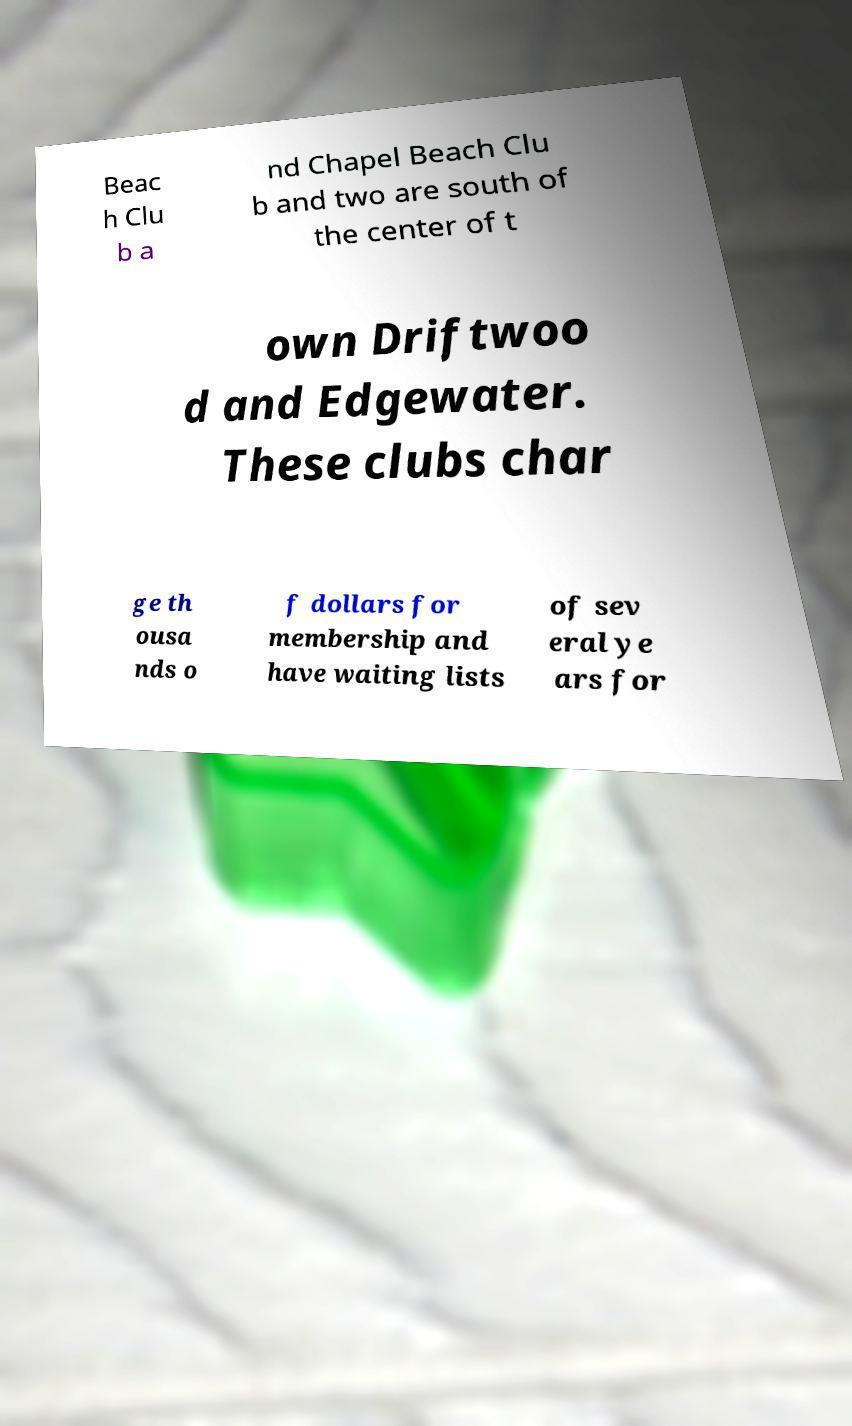Could you extract and type out the text from this image? Beac h Clu b a nd Chapel Beach Clu b and two are south of the center of t own Driftwoo d and Edgewater. These clubs char ge th ousa nds o f dollars for membership and have waiting lists of sev eral ye ars for 